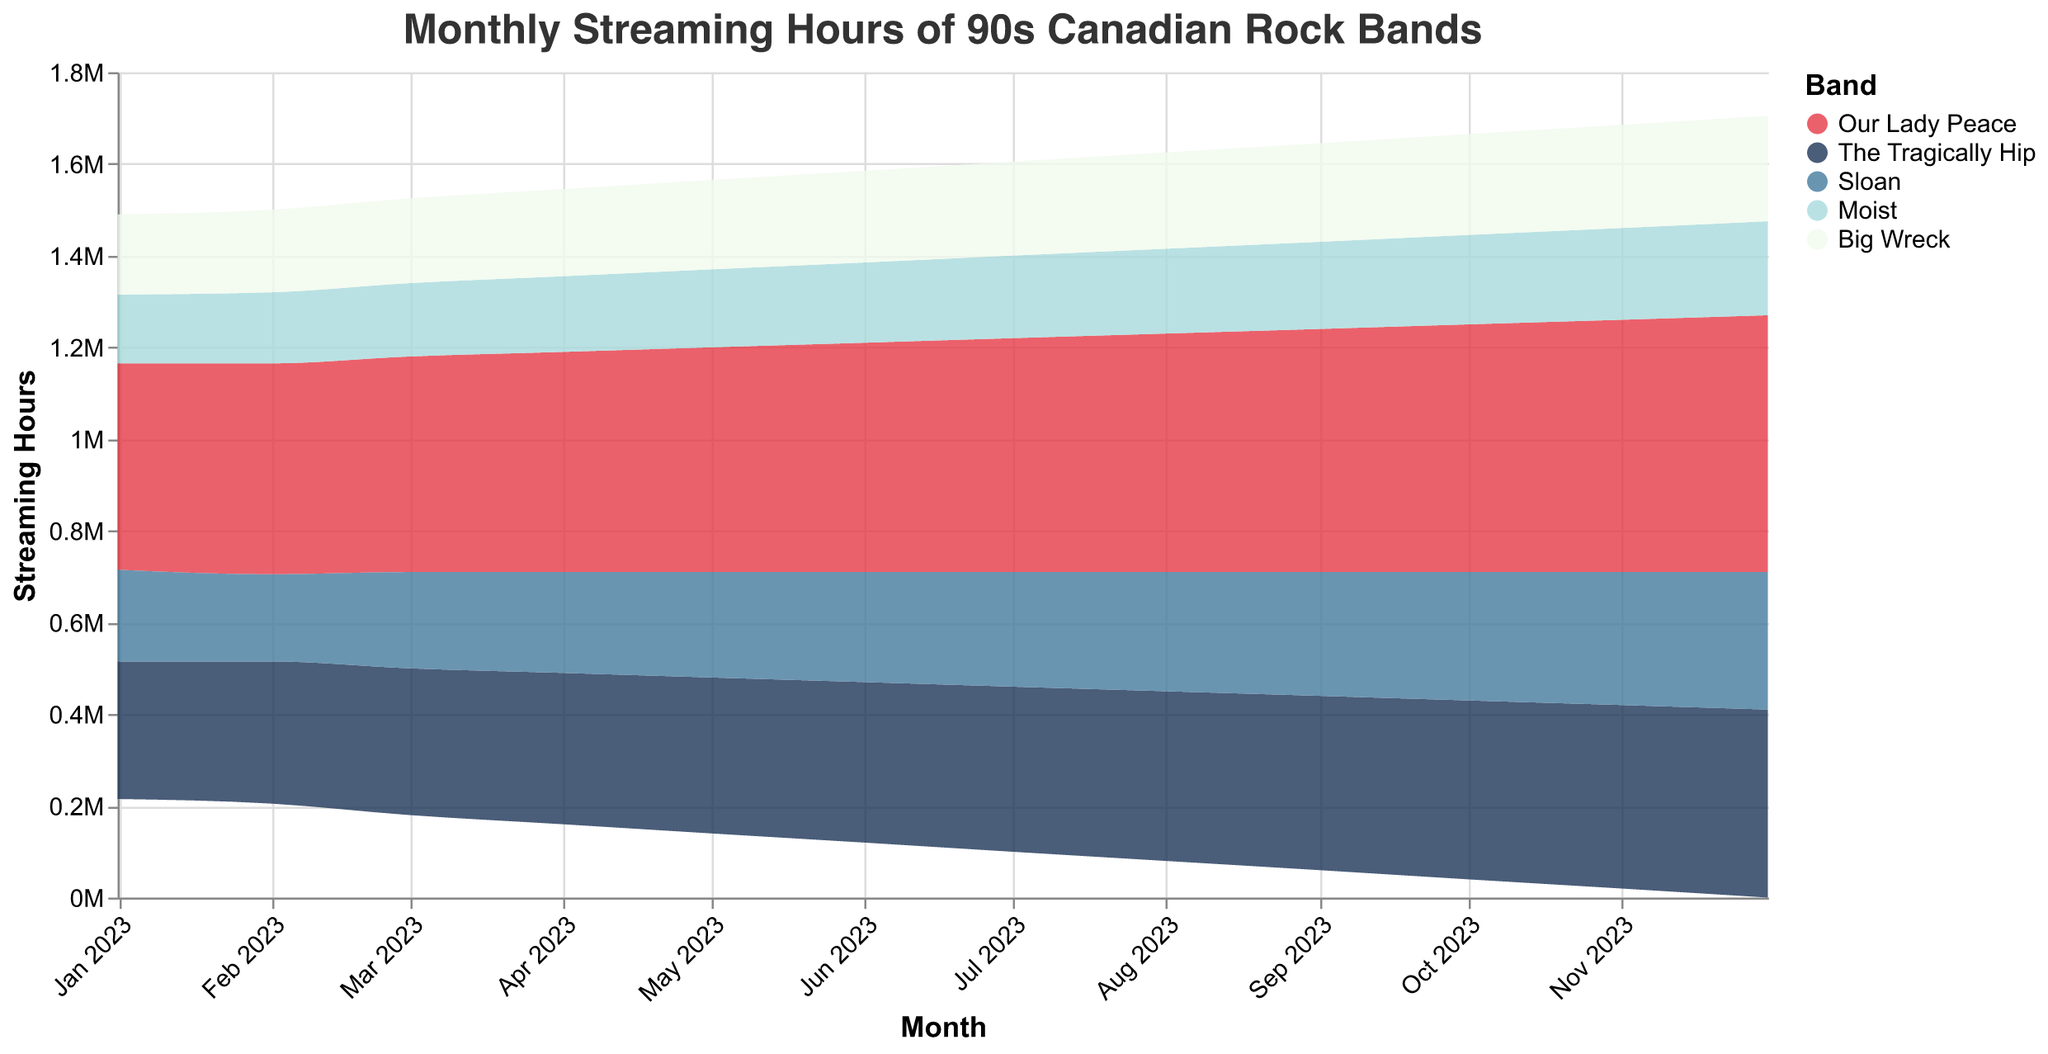What's the title of the figure? The title is usually displayed at the top of the figure. Referring to the provided code, the title is "Monthly Streaming Hours of 90s Canadian Rock Bands."
Answer: Monthly Streaming Hours of 90s Canadian Rock Bands Which band had the highest streaming hours in January 2023? Look at the data for January 2023 and compare the streaming hours for each band. Our Lady Peace has 450,000 streaming hours, the highest compared to the other bands.
Answer: Our Lady Peace How did the streaming hours for The Tragically Hip change from January to December 2023? Compare the streaming hours for The Tragically Hip in January (300,000) and December (410,000). The change is calculated as 410,000 - 300,000.
Answer: Increased by 110,000 What is the sum of streaming hours for Sloan and Moist in April 2023? Look at the April 2023 data for Sloan (220,000) and Moist (165,000). The sum is 220,000 + 165,000.
Answer: 385,000 Which month had the highest total streaming hours for all bands combined? Sum the streaming hours of all bands for each month and compare. The highest combined streaming hours occur in December 2023.
Answer: December 2023 How much did Our Lady Peace's streaming hours increase from June 2023 to July 2023? Compare Our Lady Peace's streaming hours in June (500,000) and July (510,000). The increase is calculated as 510,000 - 500,000.
Answer: 10,000 Which band experienced the smallest increase in streaming hours from August to September 2023? Compare the streaming hours for each band from August to September. Sloan increased from 260,000 to 270,000, which is the smallest increase of 10,000.
Answer: Sloan Which month shows a crossing point in streaming hours between Moist and Big Wreck? Looking at the data, both Moist and Big Wreck have the same streaming hours in January 2023 (Moist: 150,000, Big Wreck: 175,000) and then these patterns diverge; no crossing point is found.
Answer: None What is the average streaming hours for Big Wreck over the entire year? Sum the streaming hours for Big Wreck for each month and divide by 12. The total is 2,265,000, so the average is 2,265,000 / 12.
Answer: 188,750 By how much did streaming hours for Our Lady Peace surpass those of The Tragically Hip in December 2023? Compare Our Lady Peace's streaming hours in December (560,000) with The Tragically Hip's (410,000). The difference is 560,000 - 410,000.
Answer: 150,000 